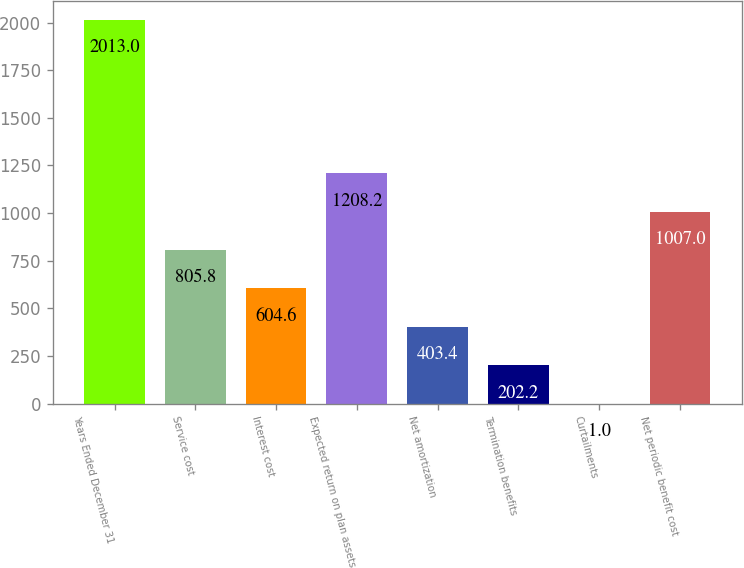Convert chart to OTSL. <chart><loc_0><loc_0><loc_500><loc_500><bar_chart><fcel>Years Ended December 31<fcel>Service cost<fcel>Interest cost<fcel>Expected return on plan assets<fcel>Net amortization<fcel>Termination benefits<fcel>Curtailments<fcel>Net periodic benefit cost<nl><fcel>2013<fcel>805.8<fcel>604.6<fcel>1208.2<fcel>403.4<fcel>202.2<fcel>1<fcel>1007<nl></chart> 